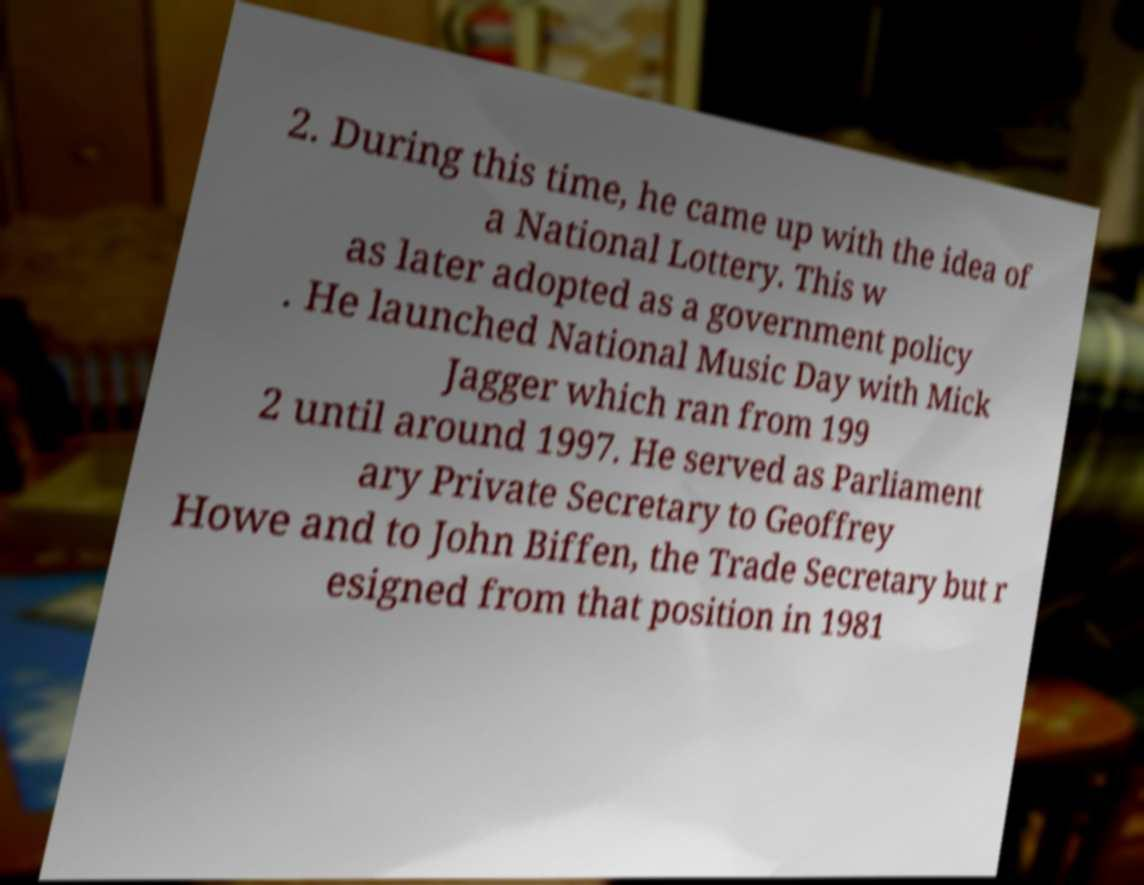For documentation purposes, I need the text within this image transcribed. Could you provide that? 2. During this time, he came up with the idea of a National Lottery. This w as later adopted as a government policy . He launched National Music Day with Mick Jagger which ran from 199 2 until around 1997. He served as Parliament ary Private Secretary to Geoffrey Howe and to John Biffen, the Trade Secretary but r esigned from that position in 1981 